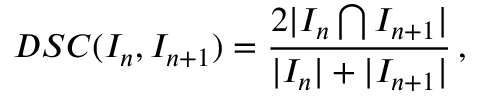Convert formula to latex. <formula><loc_0><loc_0><loc_500><loc_500>D S C ( I _ { n } , I _ { n + 1 } ) = \frac { 2 | I _ { n } \bigcap I _ { n + 1 } | } { | I _ { n } | + | I _ { n + 1 } | } \, ,</formula> 